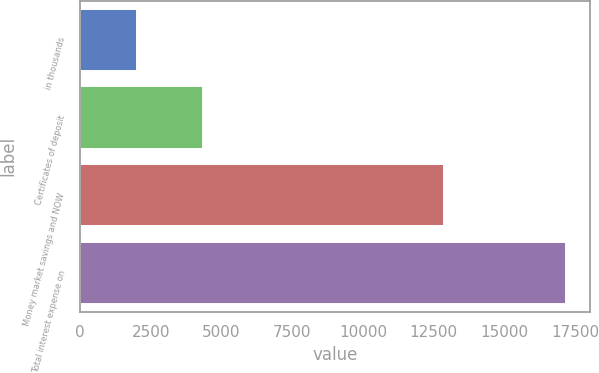<chart> <loc_0><loc_0><loc_500><loc_500><bar_chart><fcel>in thousands<fcel>Certificates of deposit<fcel>Money market savings and NOW<fcel>Total interest expense on<nl><fcel>2017<fcel>4325<fcel>12859<fcel>17184<nl></chart> 